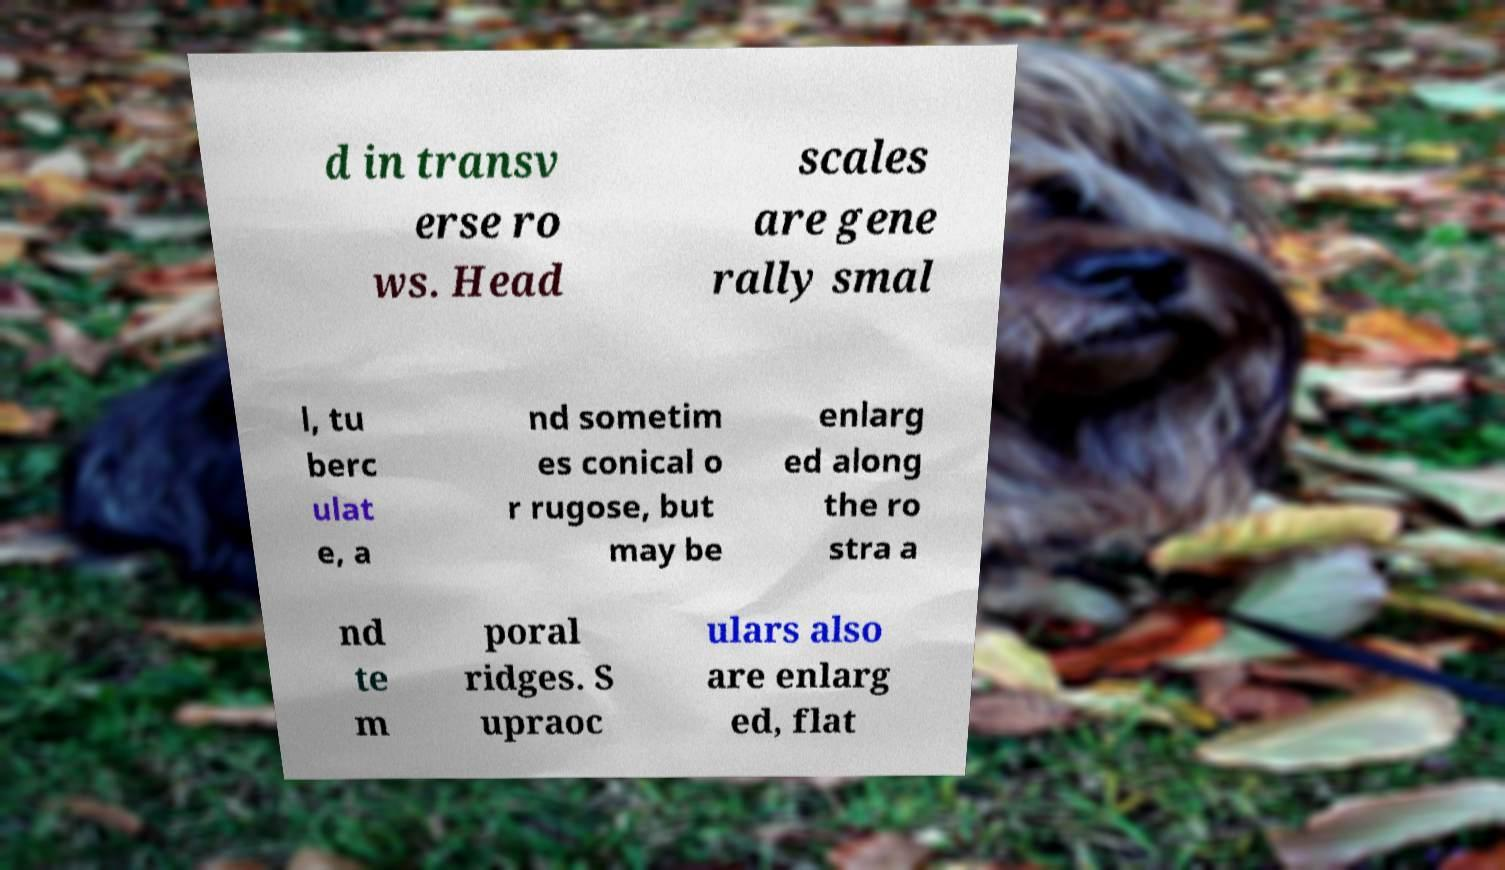Please read and relay the text visible in this image. What does it say? d in transv erse ro ws. Head scales are gene rally smal l, tu berc ulat e, a nd sometim es conical o r rugose, but may be enlarg ed along the ro stra a nd te m poral ridges. S upraoc ulars also are enlarg ed, flat 